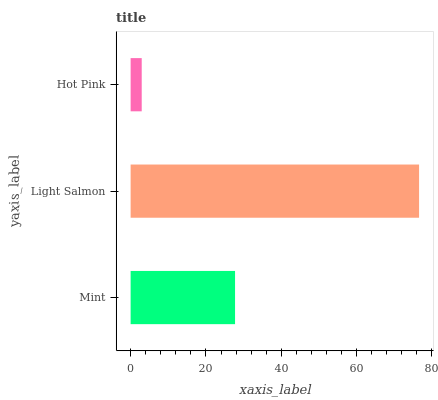Is Hot Pink the minimum?
Answer yes or no. Yes. Is Light Salmon the maximum?
Answer yes or no. Yes. Is Light Salmon the minimum?
Answer yes or no. No. Is Hot Pink the maximum?
Answer yes or no. No. Is Light Salmon greater than Hot Pink?
Answer yes or no. Yes. Is Hot Pink less than Light Salmon?
Answer yes or no. Yes. Is Hot Pink greater than Light Salmon?
Answer yes or no. No. Is Light Salmon less than Hot Pink?
Answer yes or no. No. Is Mint the high median?
Answer yes or no. Yes. Is Mint the low median?
Answer yes or no. Yes. Is Light Salmon the high median?
Answer yes or no. No. Is Light Salmon the low median?
Answer yes or no. No. 